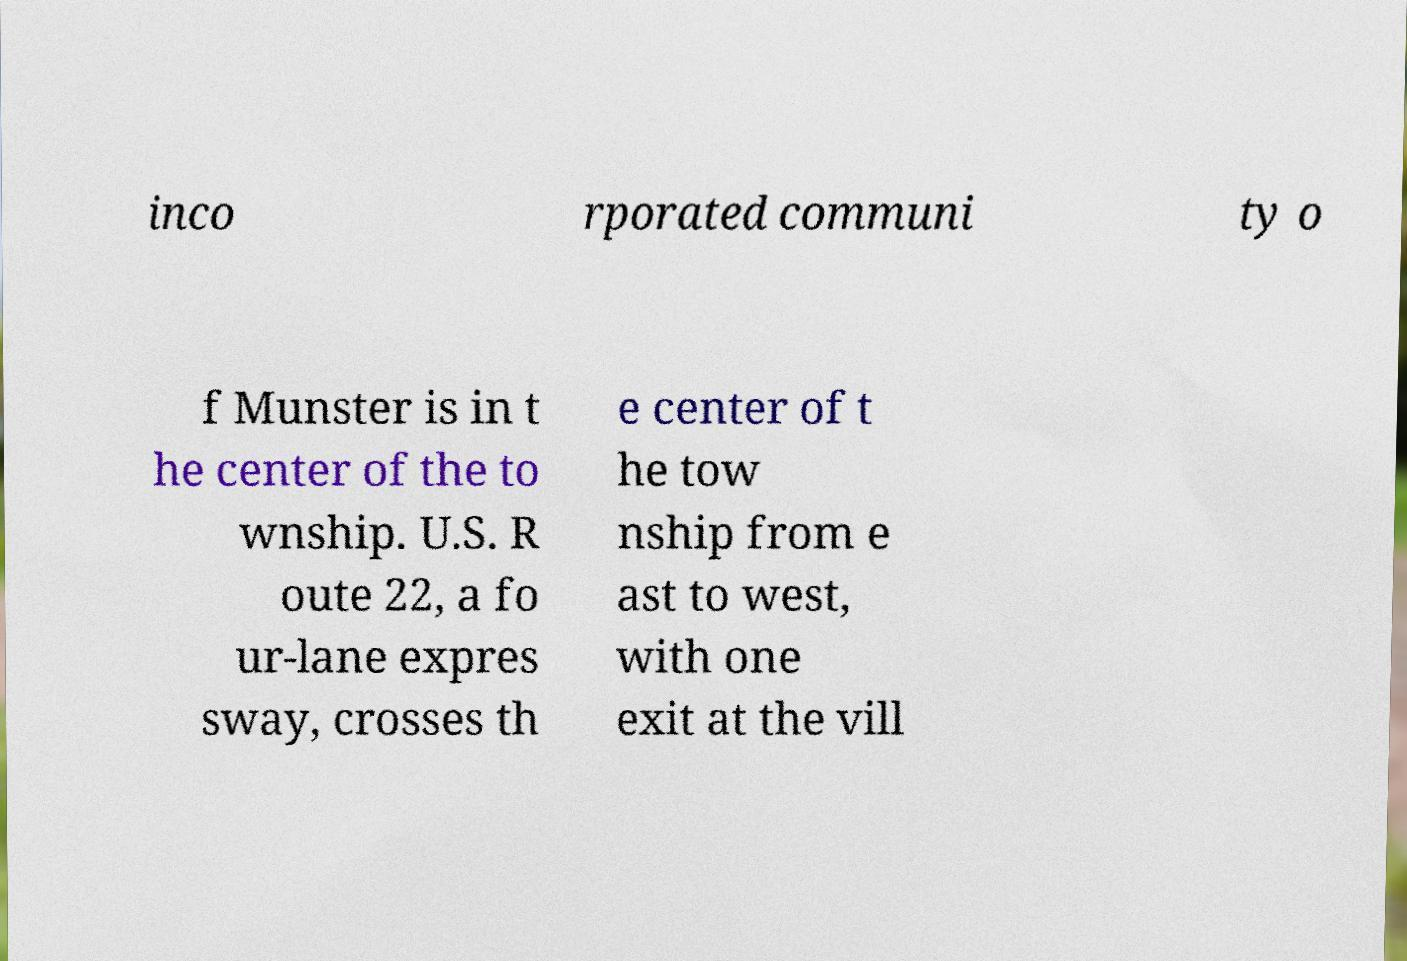Can you read and provide the text displayed in the image?This photo seems to have some interesting text. Can you extract and type it out for me? inco rporated communi ty o f Munster is in t he center of the to wnship. U.S. R oute 22, a fo ur-lane expres sway, crosses th e center of t he tow nship from e ast to west, with one exit at the vill 